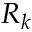<formula> <loc_0><loc_0><loc_500><loc_500>R _ { k }</formula> 